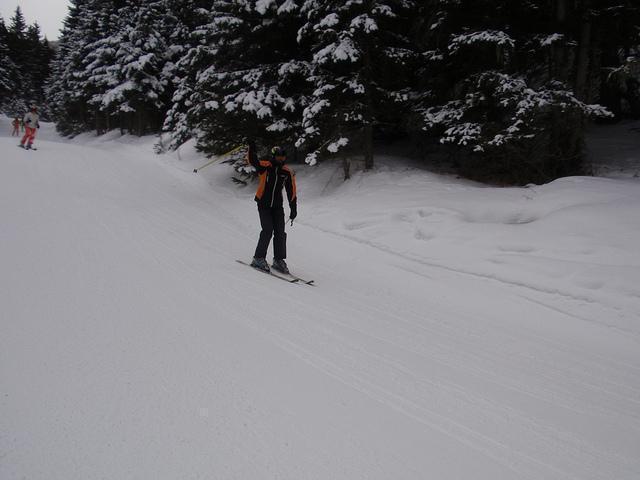Why is the man raising his arm while skiing?
Choose the right answer from the provided options to respond to the question.
Options: Getting help, climbing, claiming victory, doing tricks. Claiming victory. 